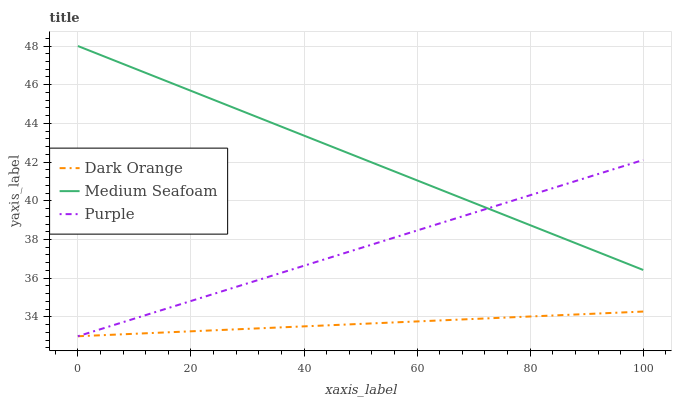Does Dark Orange have the minimum area under the curve?
Answer yes or no. Yes. Does Medium Seafoam have the maximum area under the curve?
Answer yes or no. Yes. Does Medium Seafoam have the minimum area under the curve?
Answer yes or no. No. Does Dark Orange have the maximum area under the curve?
Answer yes or no. No. Is Dark Orange the smoothest?
Answer yes or no. Yes. Is Purple the roughest?
Answer yes or no. Yes. Is Medium Seafoam the smoothest?
Answer yes or no. No. Is Medium Seafoam the roughest?
Answer yes or no. No. Does Purple have the lowest value?
Answer yes or no. Yes. Does Medium Seafoam have the lowest value?
Answer yes or no. No. Does Medium Seafoam have the highest value?
Answer yes or no. Yes. Does Dark Orange have the highest value?
Answer yes or no. No. Is Dark Orange less than Medium Seafoam?
Answer yes or no. Yes. Is Medium Seafoam greater than Dark Orange?
Answer yes or no. Yes. Does Purple intersect Dark Orange?
Answer yes or no. Yes. Is Purple less than Dark Orange?
Answer yes or no. No. Is Purple greater than Dark Orange?
Answer yes or no. No. Does Dark Orange intersect Medium Seafoam?
Answer yes or no. No. 